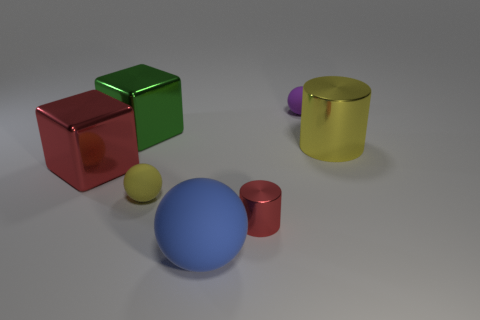What is the size of the red cylinder?
Ensure brevity in your answer.  Small. There is a rubber object that is in front of the purple rubber thing and behind the big sphere; what shape is it?
Ensure brevity in your answer.  Sphere. What color is the large matte object that is the same shape as the small purple matte thing?
Offer a very short reply. Blue. How many things are metal things that are left of the small purple sphere or matte balls to the left of the tiny purple rubber sphere?
Offer a very short reply. 5. The big yellow object has what shape?
Provide a succinct answer. Cylinder. What shape is the big object that is the same color as the small shiny object?
Provide a succinct answer. Cube. What number of big green objects have the same material as the small red cylinder?
Provide a short and direct response. 1. What is the color of the big cylinder?
Ensure brevity in your answer.  Yellow. The matte thing that is the same size as the yellow ball is what color?
Make the answer very short. Purple. Are there any big cubes that have the same color as the large ball?
Ensure brevity in your answer.  No. 